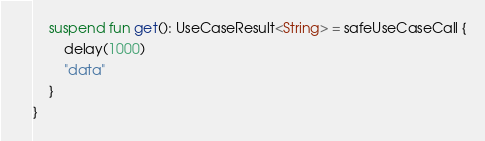Convert code to text. <code><loc_0><loc_0><loc_500><loc_500><_Kotlin_>
    suspend fun get(): UseCaseResult<String> = safeUseCaseCall {
        delay(1000)
        "data"
    }
}
</code> 